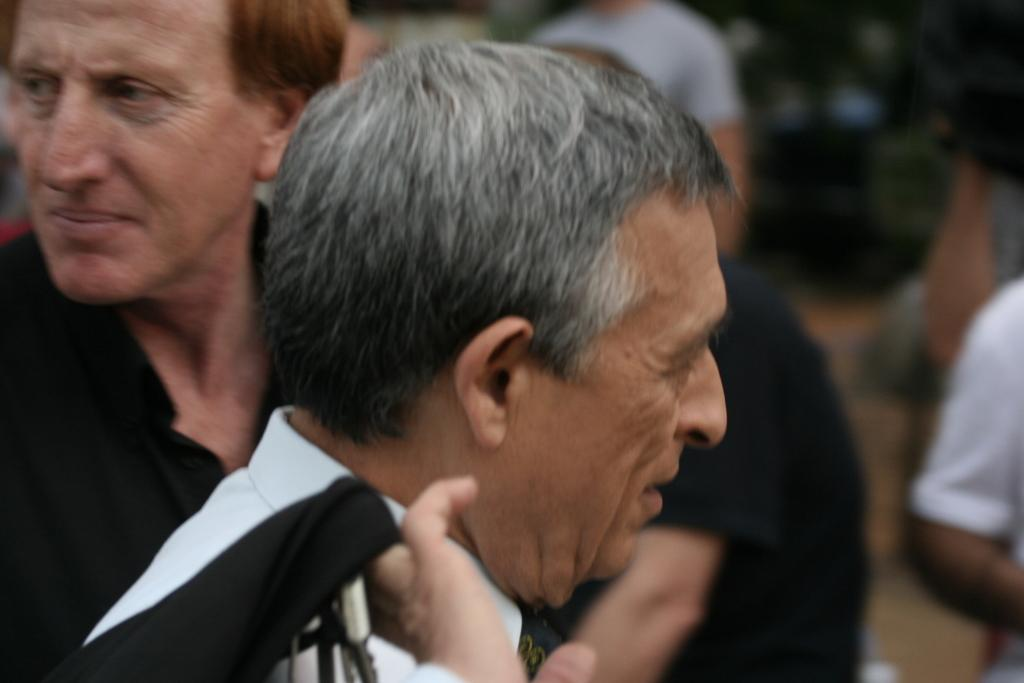How many people are in the image? There are persons in the image, but the exact number is not specified. What can be observed about the background of the image? The background of the image is blurry. What type of metal can be seen in the cemetery in the image? There is no mention of a cemetery or metal in the image, so it is not possible to answer that question. 